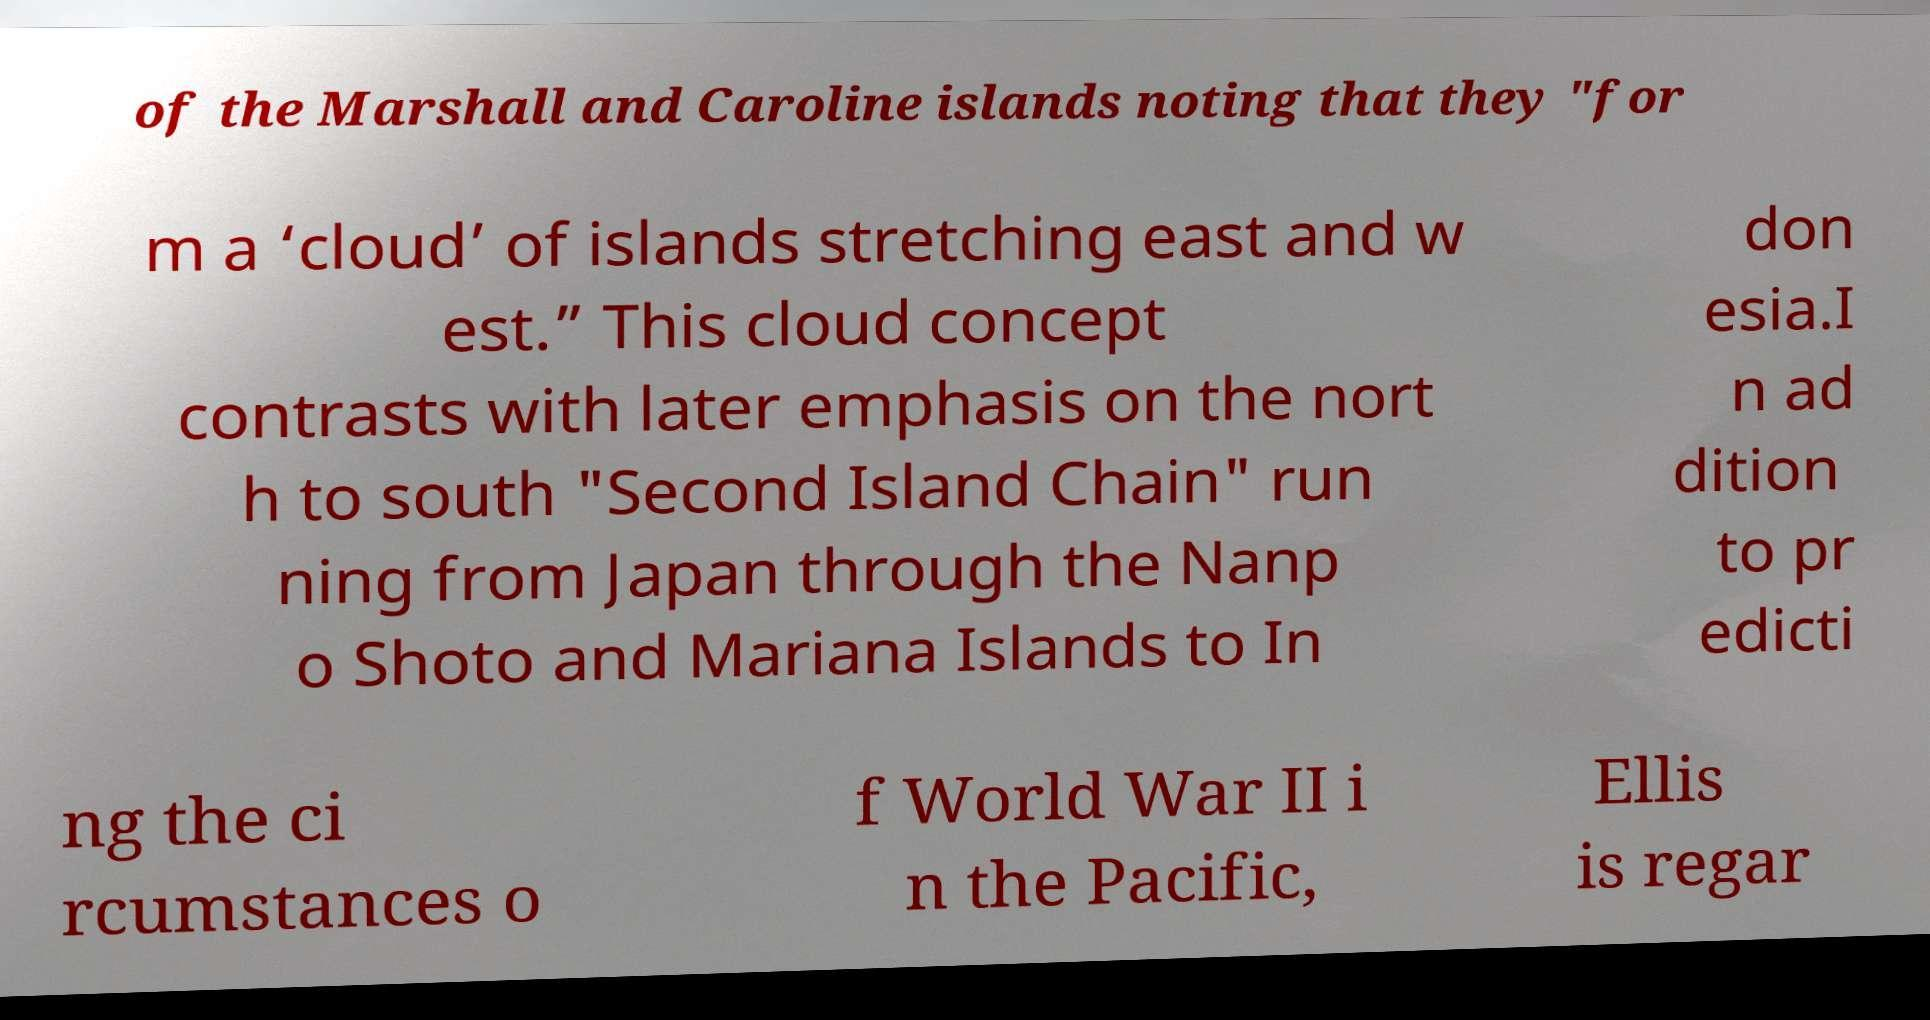For documentation purposes, I need the text within this image transcribed. Could you provide that? of the Marshall and Caroline islands noting that they "for m a ‘cloud’ of islands stretching east and w est.” This cloud concept contrasts with later emphasis on the nort h to south "Second Island Chain" run ning from Japan through the Nanp o Shoto and Mariana Islands to In don esia.I n ad dition to pr edicti ng the ci rcumstances o f World War II i n the Pacific, Ellis is regar 